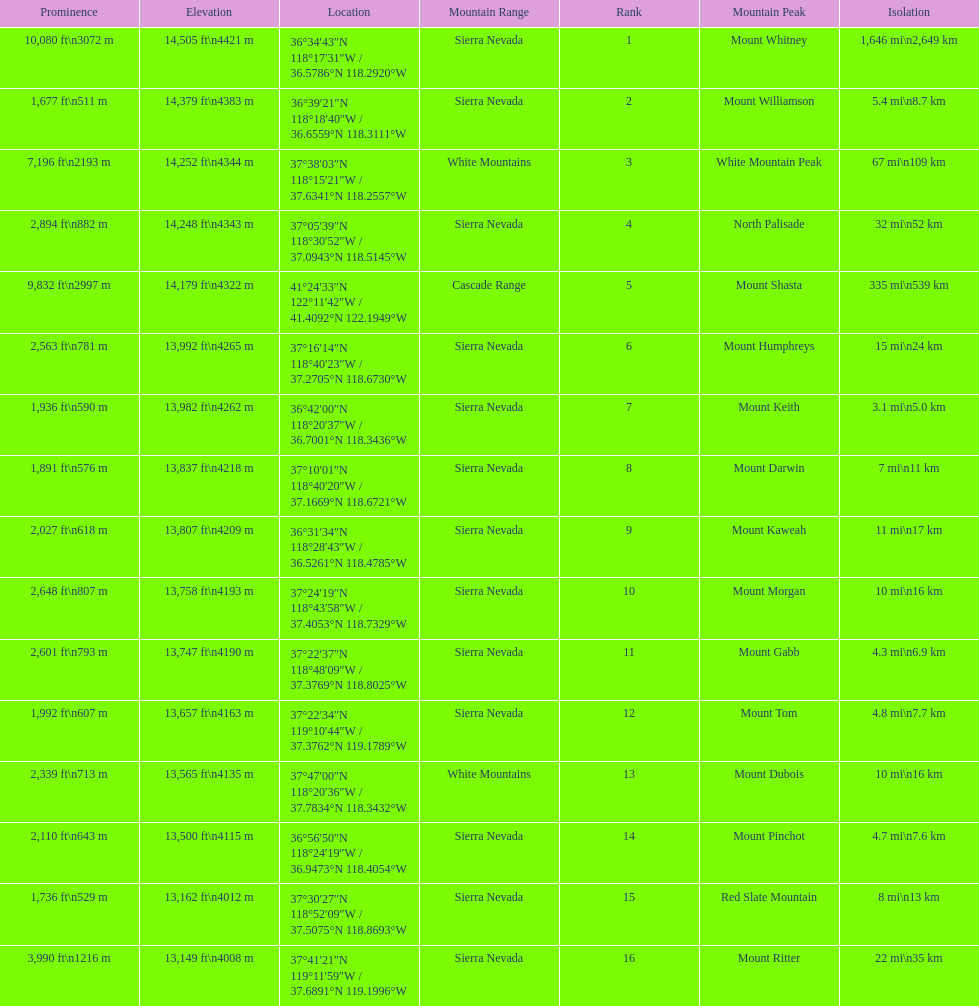Which mountain peak has the least isolation? Mount Keith. 